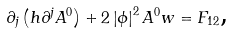<formula> <loc_0><loc_0><loc_500><loc_500>\partial _ { j } \left ( h \partial ^ { j } A ^ { 0 } \right ) + 2 \left | \phi \right | ^ { 2 } A ^ { 0 } w = F _ { 1 2 } \text {,}</formula> 